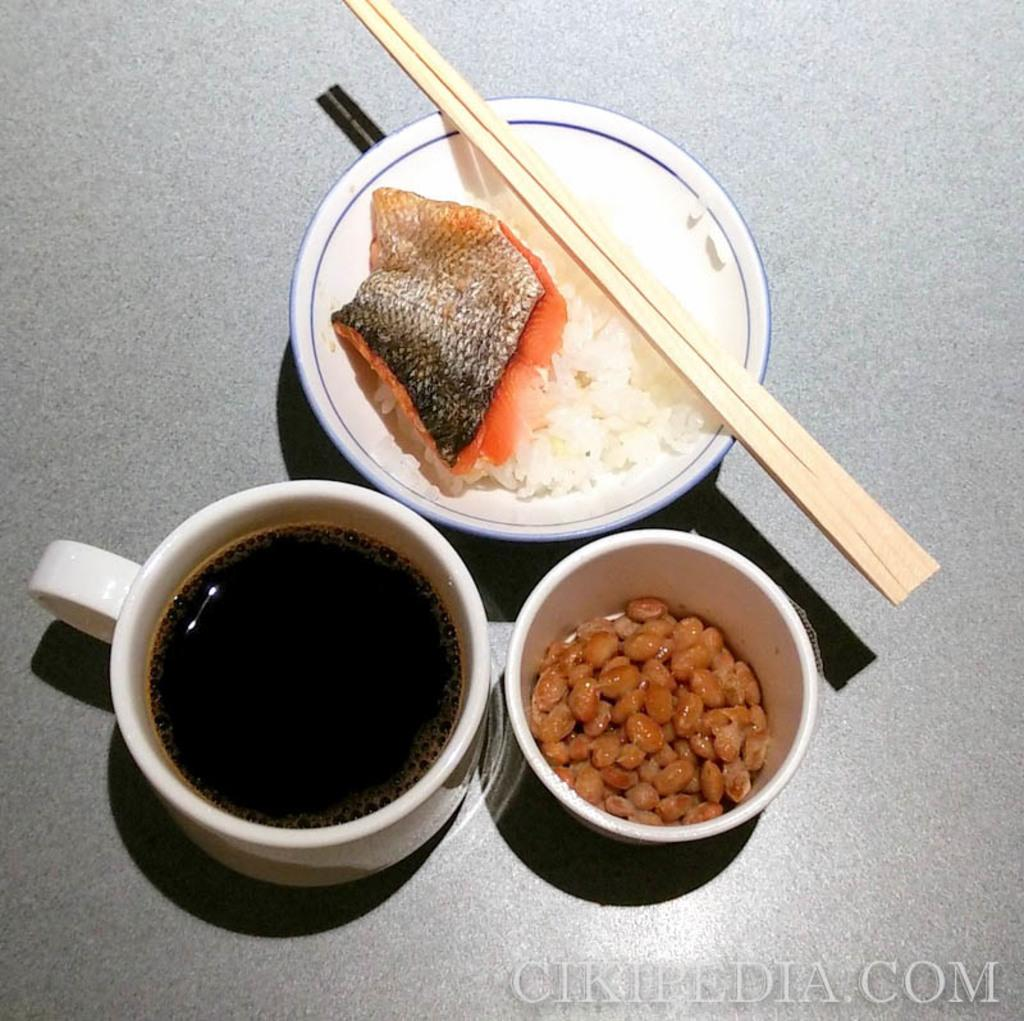How many bowls are present in the image? There are two bowls in the image. What is inside the bowls? The bowls contain food items. What else can be seen in the image besides the bowls? There is a cup in the image, and it contains a drink. Are there any utensils in the image? A: Yes, there are two chopsticks in the image. What type of square object can be seen in the image? There is no square object present in the image. Can you tell me how many cows are in the image? There are no cows present in the image. 